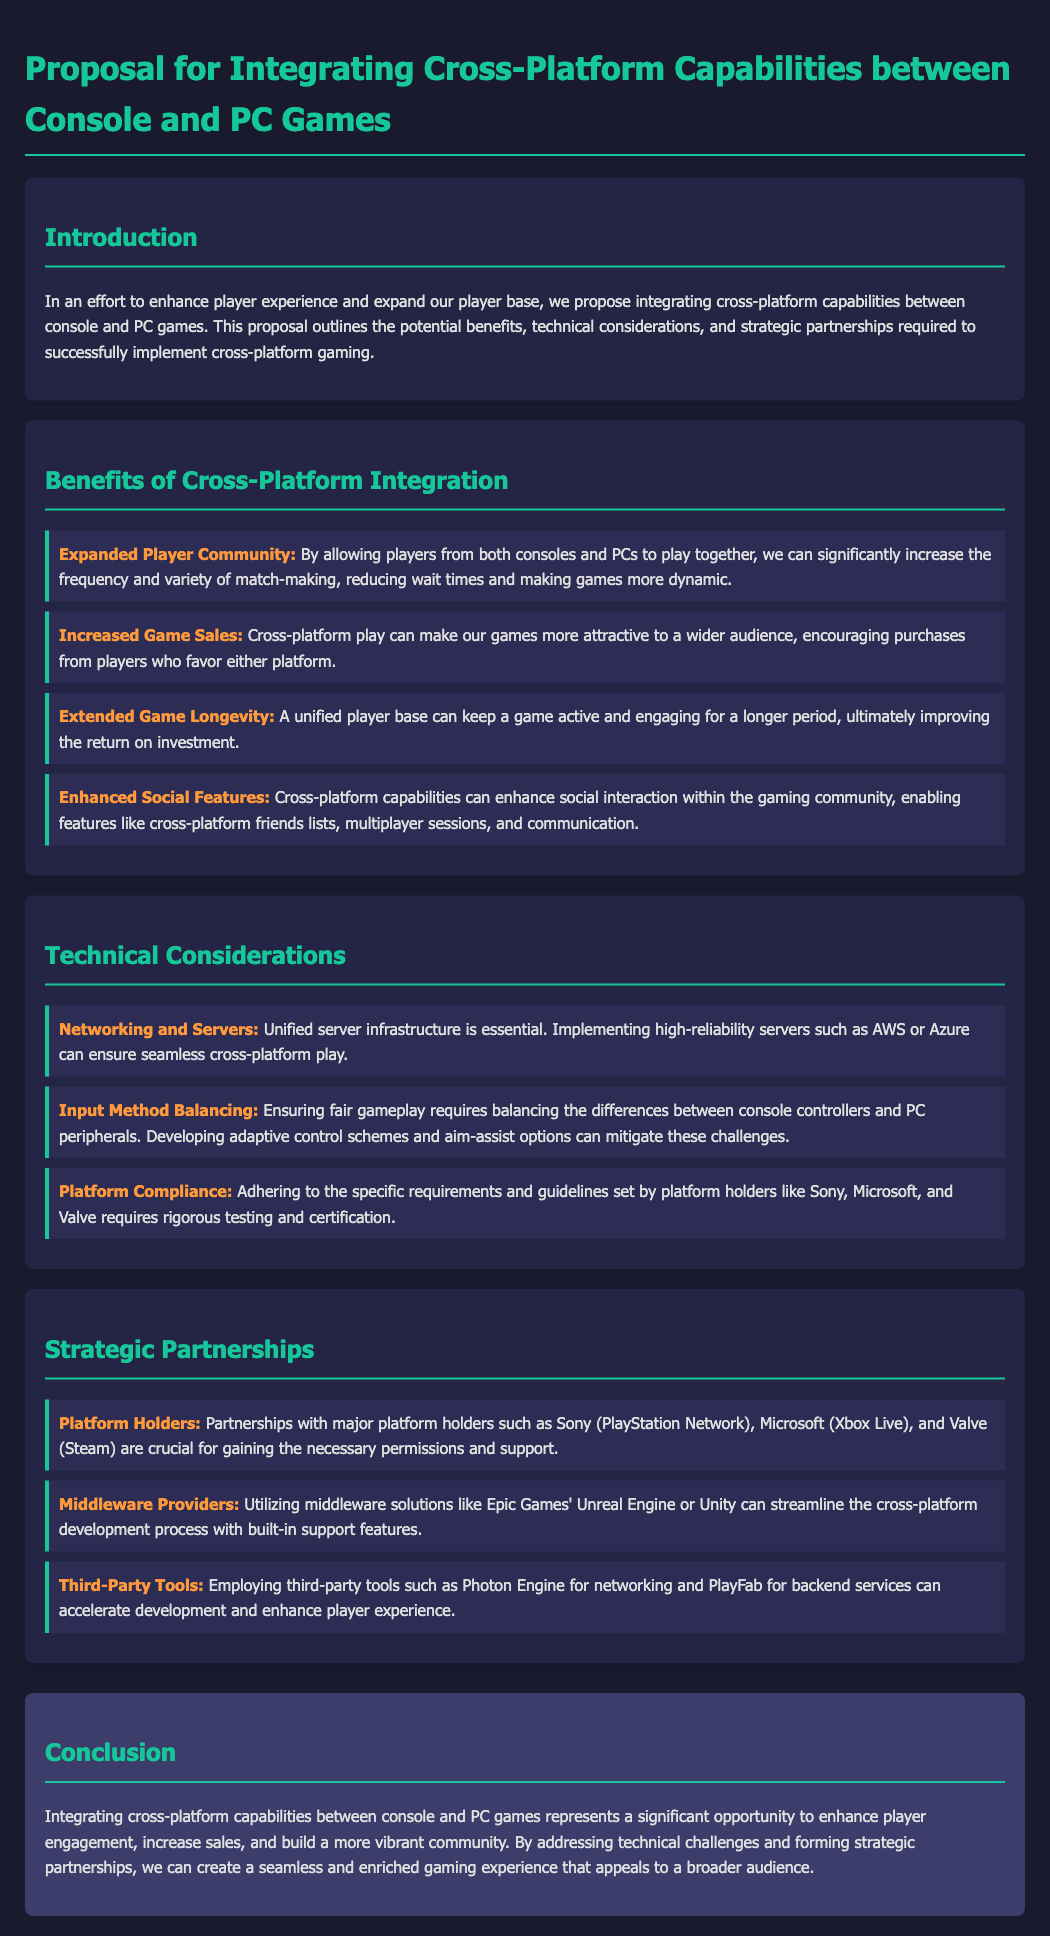What is the main purpose of the proposal? The main purpose of the proposal is to enhance player experience and expand the player base through integrating cross-platform capabilities.
Answer: Enhance player experience What is one benefit of cross-platform integration? One benefit listed in the document is the expanded player community that increases match-making frequency and variety.
Answer: Expanded player community Which technology is recommended for networking and servers? The document suggests implementing high-reliability servers like AWS or Azure for seamless cross-platform play.
Answer: AWS or Azure What role do platform holders play in this proposal? Partnerships with major platform holders are crucial for gaining necessary permissions and support for the project.
Answer: Necessary permissions What is a technical challenge mentioned in the proposal? The proposal mentions input method balancing as a technical consideration that requires addressing the differences between console controllers and PC peripherals.
Answer: Input method balancing What is the expected outcome of integrating cross-platform capabilities? The expected outcome includes enhancing player engagement and building a more vibrant community.
Answer: Enhance player engagement How many strategic partnership areas are mentioned in the document? The document mentions three areas for strategic partnerships, including platform holders, middleware providers, and third-party tools.
Answer: Three areas What does the proposal conclude about the opportunity presented by cross-platform gaming? The conclusion states that it represents a significant opportunity to enhance player engagement and community building.
Answer: Significant opportunity 